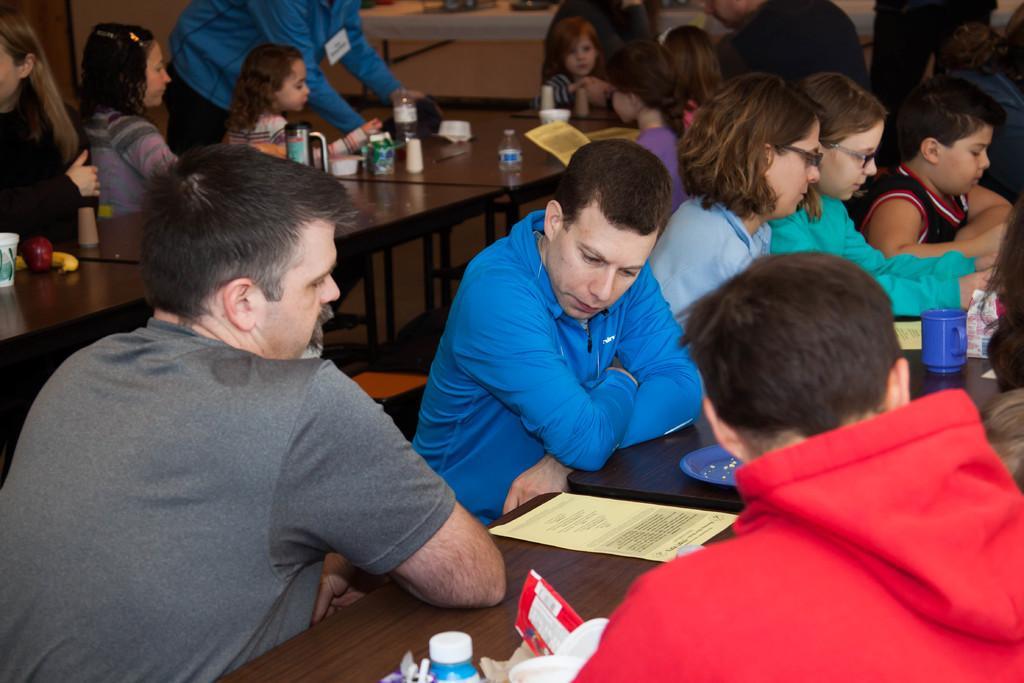Describe this image in one or two sentences. In this image we can see group of persons sitting at the tables. On the table we can see cup, paper, plate, bottles, glasses, apple and banana. In the background there is a wall. 